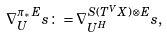<formula> <loc_0><loc_0><loc_500><loc_500>\nabla ^ { \pi _ { * } E } _ { U } s \colon = \nabla ^ { S ( T ^ { V } X ) \otimes E } _ { U ^ { H } } s ,</formula> 